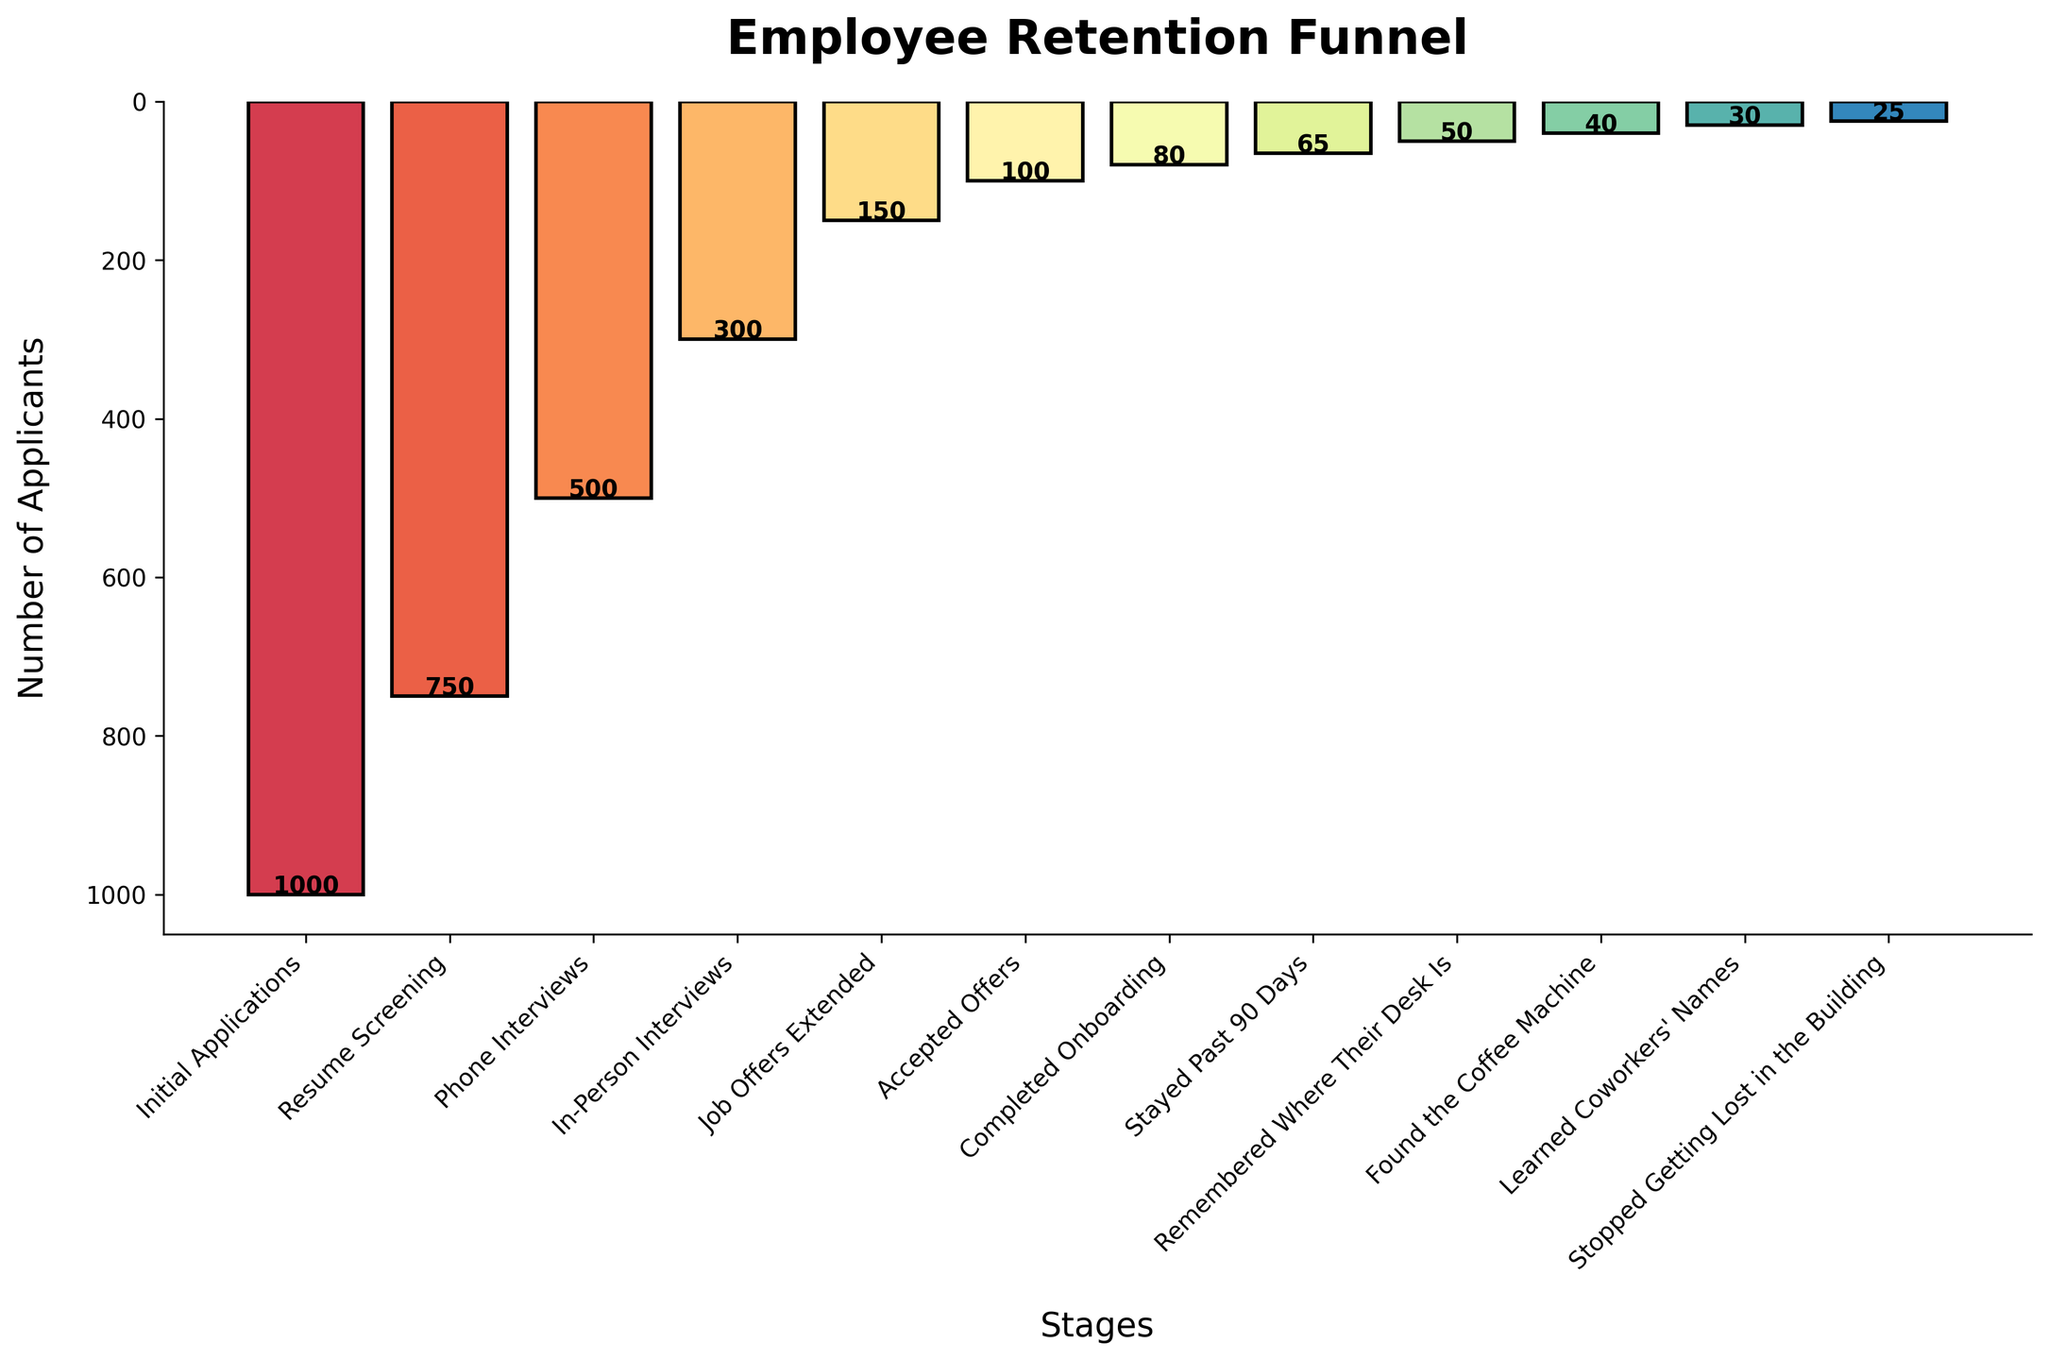What's the title of the chart? The title can be found at the top of the chart.
Answer: Employee Retention Funnel What is the number of applicants at the "Phone Interviews" stage? The number of applicants for each stage is displayed on the bar itself. Find the bar labeled "Phone Interviews" and read the number above it.
Answer: 500 What's the difference in the number of applicants between "Resume Screening" and "Initial Applications"? Subtract the number of applicants in "Resume Screening" from the number in "Initial Applications".
Answer: 250 Which stage shows the highest drop-off in the number of applicants compared to the previous stage? To find the highest drop-off, calculate the difference between each stage and its preceding one. Look for the largest difference. From "Initial Applications" (1000) to "Resume Screening" (750), the drop-off is 250, then from "Resume Screening" to "Phone Interviews" (500) the drop-off is 250. The highest drop-off can be easily observed to be from 750 to 500.
Answer: Resume Screening What's the ratio of applicants who "Learned Coworkers' Names" to those who "Found the Coffee Machine"? Divide the number of applicants who "Learned Coworkers' Names" by those who "Found the Coffee Machine".
Answer: 30/40 or 0.75 By what percentage did the number of applicants decrease from "Job Offers Extended" to "Accepted Offers"? Calculate the percentage decrease: ((150 - 100) / 150) * 100.
Answer: 33.33% Which stage has fewer applicants, "Completed Onboarding" or "Stayed Past 90 Days"? Compare the number of applicants shown above each bar for these two stages.
Answer: Stayed Past 90 Days How many applicants are there at the final stage "Stopped Getting Lost in the Building"? Look at the bar labeled "Stopped Getting Lost in the Building" and read the number above it.
Answer: 25 What is the total number of applicants who got to "Completed Onboarding"? This is a simple value read from the chart above the respective bar.
Answer: 80 How many total applicants are there considering only the stages from "Accepted Offers" to "Stopped Getting Lost in the Building"? Sum the number of applicants at each stage from "Accepted Offers" to "Stopped Getting Lost in the Building": 100 + 80 + 65 + 50 + 40 + 30 + 25.
Answer: 390 